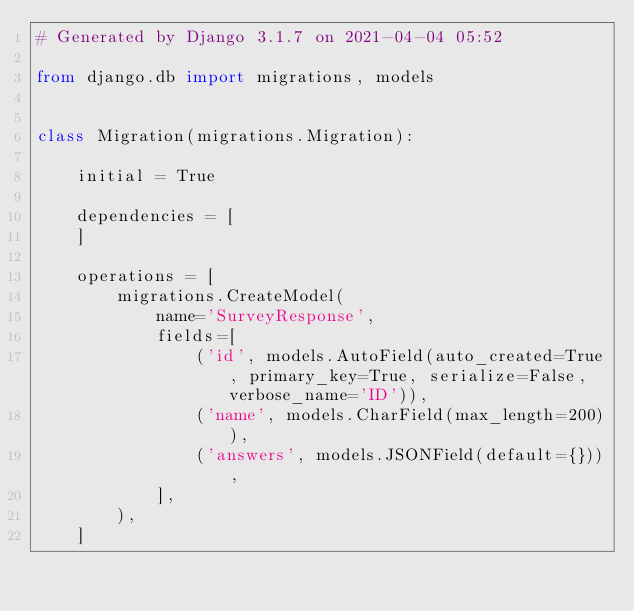<code> <loc_0><loc_0><loc_500><loc_500><_Python_># Generated by Django 3.1.7 on 2021-04-04 05:52

from django.db import migrations, models


class Migration(migrations.Migration):

    initial = True

    dependencies = [
    ]

    operations = [
        migrations.CreateModel(
            name='SurveyResponse',
            fields=[
                ('id', models.AutoField(auto_created=True, primary_key=True, serialize=False, verbose_name='ID')),
                ('name', models.CharField(max_length=200)),
                ('answers', models.JSONField(default={})),
            ],
        ),
    ]
</code> 